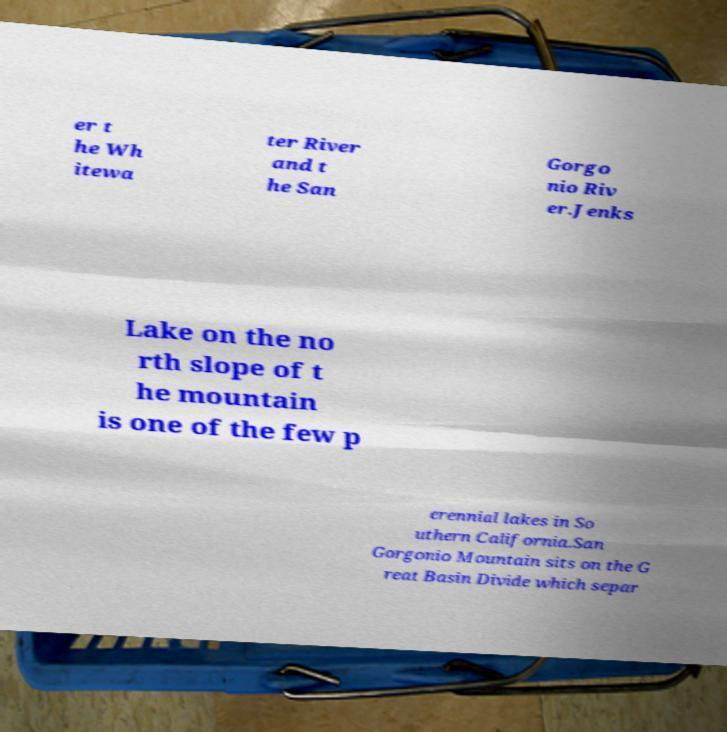Can you accurately transcribe the text from the provided image for me? er t he Wh itewa ter River and t he San Gorgo nio Riv er.Jenks Lake on the no rth slope of t he mountain is one of the few p erennial lakes in So uthern California.San Gorgonio Mountain sits on the G reat Basin Divide which separ 